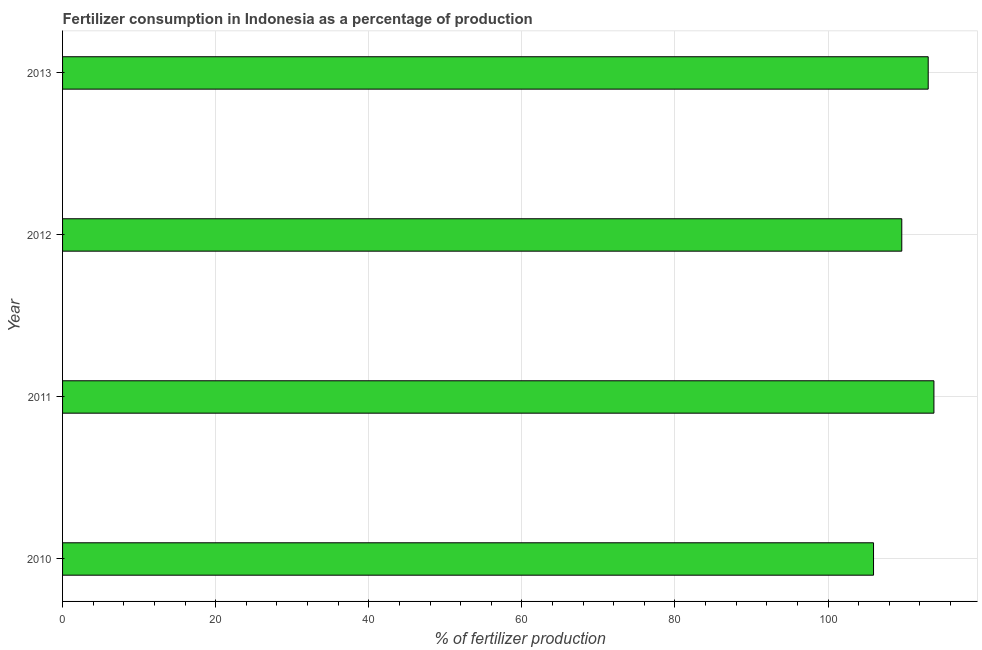Does the graph contain any zero values?
Offer a terse response. No. What is the title of the graph?
Give a very brief answer. Fertilizer consumption in Indonesia as a percentage of production. What is the label or title of the X-axis?
Ensure brevity in your answer.  % of fertilizer production. What is the label or title of the Y-axis?
Offer a terse response. Year. What is the amount of fertilizer consumption in 2012?
Provide a succinct answer. 109.63. Across all years, what is the maximum amount of fertilizer consumption?
Your answer should be very brief. 113.83. Across all years, what is the minimum amount of fertilizer consumption?
Ensure brevity in your answer.  105.94. What is the sum of the amount of fertilizer consumption?
Your response must be concise. 442.49. What is the difference between the amount of fertilizer consumption in 2010 and 2013?
Your answer should be compact. -7.14. What is the average amount of fertilizer consumption per year?
Make the answer very short. 110.62. What is the median amount of fertilizer consumption?
Offer a terse response. 111.36. In how many years, is the amount of fertilizer consumption greater than 24 %?
Your answer should be very brief. 4. Do a majority of the years between 2013 and 2012 (inclusive) have amount of fertilizer consumption greater than 84 %?
Keep it short and to the point. No. What is the ratio of the amount of fertilizer consumption in 2011 to that in 2012?
Offer a terse response. 1.04. Is the amount of fertilizer consumption in 2010 less than that in 2011?
Offer a very short reply. Yes. Is the difference between the amount of fertilizer consumption in 2010 and 2012 greater than the difference between any two years?
Your answer should be very brief. No. What is the difference between the highest and the second highest amount of fertilizer consumption?
Your answer should be compact. 0.75. Is the sum of the amount of fertilizer consumption in 2010 and 2013 greater than the maximum amount of fertilizer consumption across all years?
Make the answer very short. Yes. What is the difference between the highest and the lowest amount of fertilizer consumption?
Give a very brief answer. 7.89. How many bars are there?
Provide a succinct answer. 4. How many years are there in the graph?
Make the answer very short. 4. What is the difference between two consecutive major ticks on the X-axis?
Offer a terse response. 20. What is the % of fertilizer production in 2010?
Offer a very short reply. 105.94. What is the % of fertilizer production of 2011?
Provide a short and direct response. 113.83. What is the % of fertilizer production of 2012?
Make the answer very short. 109.63. What is the % of fertilizer production in 2013?
Your answer should be compact. 113.08. What is the difference between the % of fertilizer production in 2010 and 2011?
Provide a short and direct response. -7.89. What is the difference between the % of fertilizer production in 2010 and 2012?
Provide a succinct answer. -3.69. What is the difference between the % of fertilizer production in 2010 and 2013?
Your answer should be compact. -7.14. What is the difference between the % of fertilizer production in 2011 and 2012?
Provide a succinct answer. 4.2. What is the difference between the % of fertilizer production in 2011 and 2013?
Your answer should be compact. 0.75. What is the difference between the % of fertilizer production in 2012 and 2013?
Offer a very short reply. -3.45. What is the ratio of the % of fertilizer production in 2010 to that in 2011?
Offer a terse response. 0.93. What is the ratio of the % of fertilizer production in 2010 to that in 2013?
Make the answer very short. 0.94. What is the ratio of the % of fertilizer production in 2011 to that in 2012?
Ensure brevity in your answer.  1.04. What is the ratio of the % of fertilizer production in 2012 to that in 2013?
Provide a short and direct response. 0.97. 